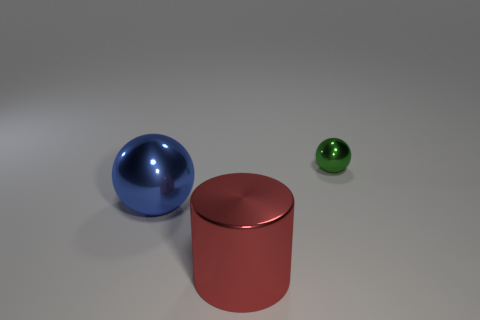Add 1 tiny cyan shiny objects. How many objects exist? 4 Subtract all cylinders. How many objects are left? 2 Add 2 gray rubber balls. How many gray rubber balls exist? 2 Subtract 1 red cylinders. How many objects are left? 2 Subtract all tiny gray matte blocks. Subtract all big metal cylinders. How many objects are left? 2 Add 3 tiny metallic spheres. How many tiny metallic spheres are left? 4 